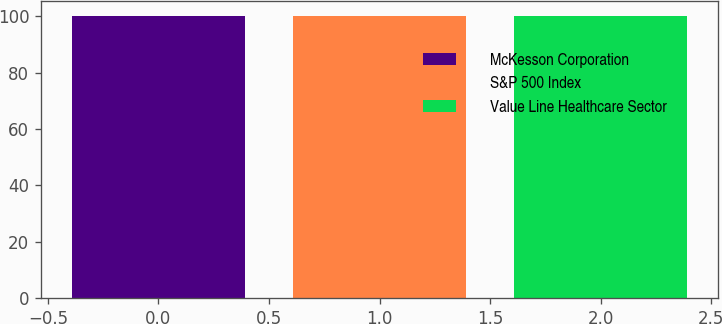Convert chart to OTSL. <chart><loc_0><loc_0><loc_500><loc_500><bar_chart><fcel>McKesson Corporation<fcel>S&P 500 Index<fcel>Value Line Healthcare Sector<nl><fcel>100<fcel>100.1<fcel>100.2<nl></chart> 